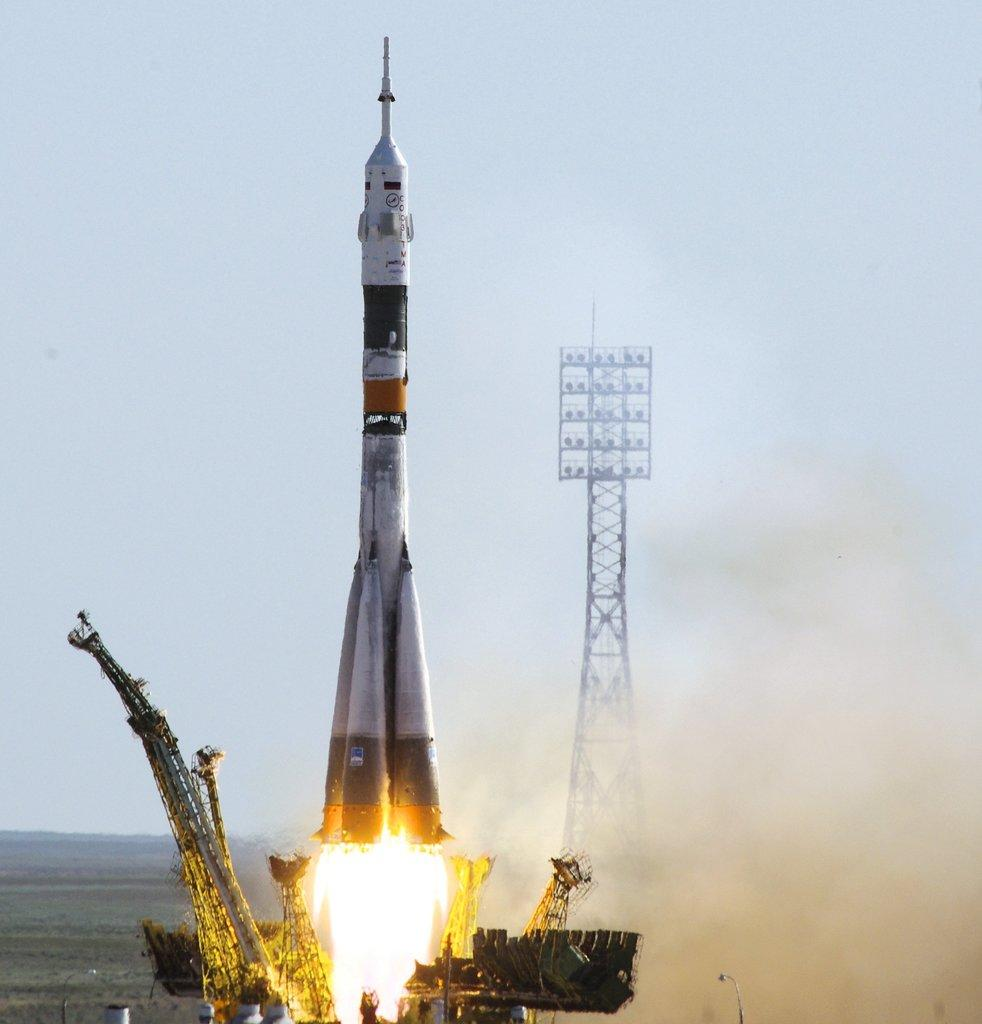What is the main subject of the image? There is a rocket in the image. What is the rocket doing in the image? The rocket is moving. What is at the bottom of the rocket? There is fire at the bottom of the rocket. What can be seen on the right side of the image? There is an iron frame on the right side of the image. What is visible at the top of the image? The sky is visible at the top of the image. Can you tell me the value of the fireman's umbrella in the image? There is no fireman or umbrella present in the image. 